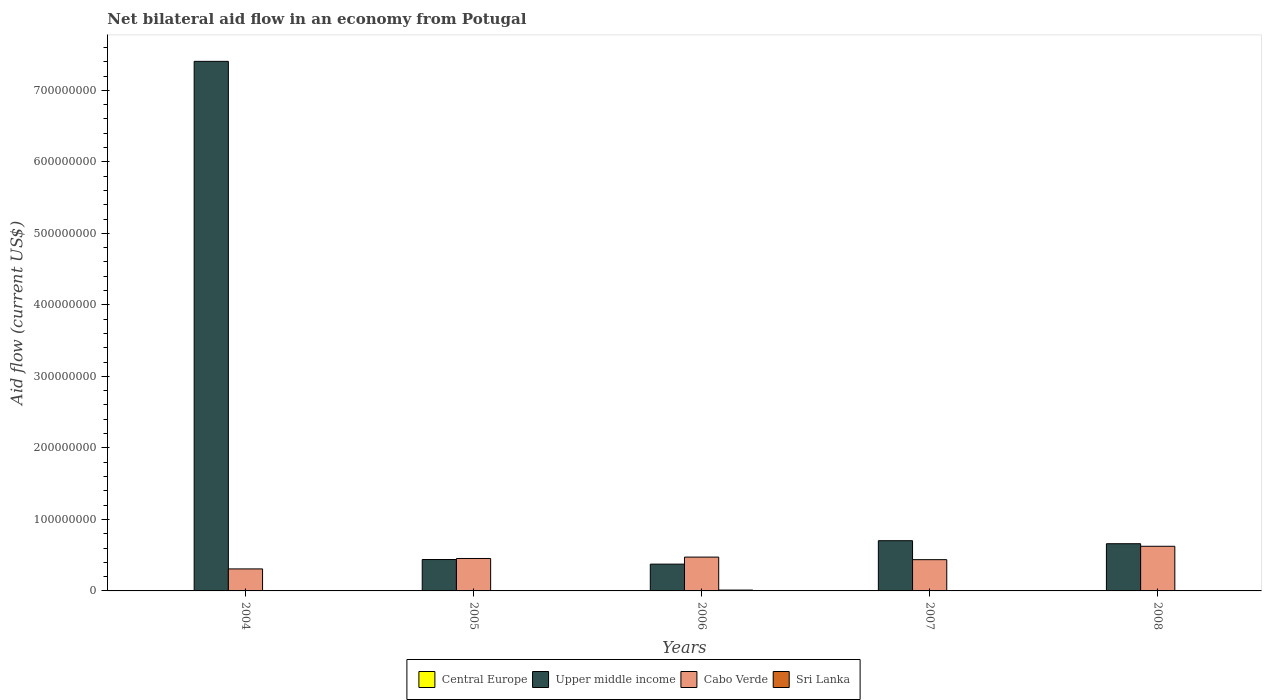How many groups of bars are there?
Your answer should be compact. 5. Are the number of bars on each tick of the X-axis equal?
Provide a succinct answer. Yes. How many bars are there on the 2nd tick from the right?
Make the answer very short. 4. What is the label of the 3rd group of bars from the left?
Provide a succinct answer. 2006. In how many cases, is the number of bars for a given year not equal to the number of legend labels?
Offer a terse response. 0. What is the net bilateral aid flow in Cabo Verde in 2005?
Offer a very short reply. 4.54e+07. Across all years, what is the maximum net bilateral aid flow in Upper middle income?
Offer a terse response. 7.41e+08. Across all years, what is the minimum net bilateral aid flow in Sri Lanka?
Ensure brevity in your answer.  10000. In which year was the net bilateral aid flow in Central Europe minimum?
Ensure brevity in your answer.  2005. What is the total net bilateral aid flow in Sri Lanka in the graph?
Ensure brevity in your answer.  1.89e+06. What is the difference between the net bilateral aid flow in Upper middle income in 2004 and that in 2005?
Your answer should be very brief. 6.97e+08. What is the difference between the net bilateral aid flow in Central Europe in 2008 and the net bilateral aid flow in Cabo Verde in 2007?
Provide a short and direct response. -4.36e+07. What is the average net bilateral aid flow in Central Europe per year?
Provide a short and direct response. 1.84e+05. In the year 2006, what is the difference between the net bilateral aid flow in Central Europe and net bilateral aid flow in Upper middle income?
Keep it short and to the point. -3.74e+07. Is the net bilateral aid flow in Sri Lanka in 2004 less than that in 2005?
Your response must be concise. Yes. What is the difference between the highest and the second highest net bilateral aid flow in Cabo Verde?
Provide a succinct answer. 1.51e+07. What is the difference between the highest and the lowest net bilateral aid flow in Upper middle income?
Provide a short and direct response. 7.03e+08. Is the sum of the net bilateral aid flow in Sri Lanka in 2004 and 2005 greater than the maximum net bilateral aid flow in Cabo Verde across all years?
Your answer should be compact. No. What does the 1st bar from the left in 2006 represents?
Your answer should be compact. Central Europe. What does the 4th bar from the right in 2008 represents?
Ensure brevity in your answer.  Central Europe. Are the values on the major ticks of Y-axis written in scientific E-notation?
Provide a succinct answer. No. Does the graph contain any zero values?
Your answer should be very brief. No. Where does the legend appear in the graph?
Your answer should be very brief. Bottom center. What is the title of the graph?
Provide a short and direct response. Net bilateral aid flow in an economy from Potugal. Does "Europe(all income levels)" appear as one of the legend labels in the graph?
Offer a very short reply. No. What is the label or title of the X-axis?
Provide a short and direct response. Years. What is the label or title of the Y-axis?
Your answer should be very brief. Aid flow (current US$). What is the Aid flow (current US$) in Central Europe in 2004?
Give a very brief answer. 5.50e+05. What is the Aid flow (current US$) in Upper middle income in 2004?
Keep it short and to the point. 7.41e+08. What is the Aid flow (current US$) in Cabo Verde in 2004?
Provide a succinct answer. 3.08e+07. What is the Aid flow (current US$) of Central Europe in 2005?
Your answer should be compact. 5.00e+04. What is the Aid flow (current US$) of Upper middle income in 2005?
Make the answer very short. 4.39e+07. What is the Aid flow (current US$) in Cabo Verde in 2005?
Give a very brief answer. 4.54e+07. What is the Aid flow (current US$) in Sri Lanka in 2005?
Keep it short and to the point. 5.40e+05. What is the Aid flow (current US$) in Upper middle income in 2006?
Give a very brief answer. 3.75e+07. What is the Aid flow (current US$) of Cabo Verde in 2006?
Keep it short and to the point. 4.73e+07. What is the Aid flow (current US$) of Sri Lanka in 2006?
Offer a terse response. 1.20e+06. What is the Aid flow (current US$) of Upper middle income in 2007?
Your response must be concise. 7.02e+07. What is the Aid flow (current US$) of Cabo Verde in 2007?
Your answer should be compact. 4.37e+07. What is the Aid flow (current US$) of Upper middle income in 2008?
Provide a short and direct response. 6.60e+07. What is the Aid flow (current US$) of Cabo Verde in 2008?
Your answer should be compact. 6.24e+07. What is the Aid flow (current US$) in Sri Lanka in 2008?
Your answer should be very brief. 3.00e+04. Across all years, what is the maximum Aid flow (current US$) in Central Europe?
Ensure brevity in your answer.  5.50e+05. Across all years, what is the maximum Aid flow (current US$) of Upper middle income?
Offer a very short reply. 7.41e+08. Across all years, what is the maximum Aid flow (current US$) of Cabo Verde?
Provide a succinct answer. 6.24e+07. Across all years, what is the maximum Aid flow (current US$) of Sri Lanka?
Offer a very short reply. 1.20e+06. Across all years, what is the minimum Aid flow (current US$) in Upper middle income?
Ensure brevity in your answer.  3.75e+07. Across all years, what is the minimum Aid flow (current US$) in Cabo Verde?
Offer a very short reply. 3.08e+07. Across all years, what is the minimum Aid flow (current US$) in Sri Lanka?
Give a very brief answer. 10000. What is the total Aid flow (current US$) of Central Europe in the graph?
Ensure brevity in your answer.  9.20e+05. What is the total Aid flow (current US$) in Upper middle income in the graph?
Make the answer very short. 9.58e+08. What is the total Aid flow (current US$) of Cabo Verde in the graph?
Provide a succinct answer. 2.30e+08. What is the total Aid flow (current US$) of Sri Lanka in the graph?
Your answer should be very brief. 1.89e+06. What is the difference between the Aid flow (current US$) of Upper middle income in 2004 and that in 2005?
Your response must be concise. 6.97e+08. What is the difference between the Aid flow (current US$) in Cabo Verde in 2004 and that in 2005?
Offer a terse response. -1.46e+07. What is the difference between the Aid flow (current US$) in Sri Lanka in 2004 and that in 2005?
Ensure brevity in your answer.  -4.30e+05. What is the difference between the Aid flow (current US$) in Upper middle income in 2004 and that in 2006?
Your answer should be very brief. 7.03e+08. What is the difference between the Aid flow (current US$) of Cabo Verde in 2004 and that in 2006?
Keep it short and to the point. -1.65e+07. What is the difference between the Aid flow (current US$) in Sri Lanka in 2004 and that in 2006?
Make the answer very short. -1.09e+06. What is the difference between the Aid flow (current US$) of Central Europe in 2004 and that in 2007?
Make the answer very short. 4.30e+05. What is the difference between the Aid flow (current US$) of Upper middle income in 2004 and that in 2007?
Keep it short and to the point. 6.70e+08. What is the difference between the Aid flow (current US$) of Cabo Verde in 2004 and that in 2007?
Your response must be concise. -1.29e+07. What is the difference between the Aid flow (current US$) in Sri Lanka in 2004 and that in 2007?
Provide a short and direct response. 1.00e+05. What is the difference between the Aid flow (current US$) of Upper middle income in 2004 and that in 2008?
Your response must be concise. 6.75e+08. What is the difference between the Aid flow (current US$) in Cabo Verde in 2004 and that in 2008?
Make the answer very short. -3.17e+07. What is the difference between the Aid flow (current US$) of Upper middle income in 2005 and that in 2006?
Make the answer very short. 6.44e+06. What is the difference between the Aid flow (current US$) in Cabo Verde in 2005 and that in 2006?
Provide a succinct answer. -1.94e+06. What is the difference between the Aid flow (current US$) in Sri Lanka in 2005 and that in 2006?
Provide a succinct answer. -6.60e+05. What is the difference between the Aid flow (current US$) of Upper middle income in 2005 and that in 2007?
Provide a short and direct response. -2.63e+07. What is the difference between the Aid flow (current US$) in Cabo Verde in 2005 and that in 2007?
Your answer should be very brief. 1.66e+06. What is the difference between the Aid flow (current US$) of Sri Lanka in 2005 and that in 2007?
Ensure brevity in your answer.  5.30e+05. What is the difference between the Aid flow (current US$) of Central Europe in 2005 and that in 2008?
Give a very brief answer. -7.00e+04. What is the difference between the Aid flow (current US$) in Upper middle income in 2005 and that in 2008?
Ensure brevity in your answer.  -2.21e+07. What is the difference between the Aid flow (current US$) of Cabo Verde in 2005 and that in 2008?
Your answer should be very brief. -1.71e+07. What is the difference between the Aid flow (current US$) in Sri Lanka in 2005 and that in 2008?
Provide a short and direct response. 5.10e+05. What is the difference between the Aid flow (current US$) in Upper middle income in 2006 and that in 2007?
Give a very brief answer. -3.28e+07. What is the difference between the Aid flow (current US$) of Cabo Verde in 2006 and that in 2007?
Make the answer very short. 3.60e+06. What is the difference between the Aid flow (current US$) in Sri Lanka in 2006 and that in 2007?
Provide a succinct answer. 1.19e+06. What is the difference between the Aid flow (current US$) in Central Europe in 2006 and that in 2008?
Provide a succinct answer. -4.00e+04. What is the difference between the Aid flow (current US$) in Upper middle income in 2006 and that in 2008?
Your answer should be compact. -2.85e+07. What is the difference between the Aid flow (current US$) of Cabo Verde in 2006 and that in 2008?
Offer a very short reply. -1.51e+07. What is the difference between the Aid flow (current US$) of Sri Lanka in 2006 and that in 2008?
Provide a succinct answer. 1.17e+06. What is the difference between the Aid flow (current US$) of Upper middle income in 2007 and that in 2008?
Offer a terse response. 4.22e+06. What is the difference between the Aid flow (current US$) of Cabo Verde in 2007 and that in 2008?
Ensure brevity in your answer.  -1.87e+07. What is the difference between the Aid flow (current US$) in Central Europe in 2004 and the Aid flow (current US$) in Upper middle income in 2005?
Your answer should be compact. -4.34e+07. What is the difference between the Aid flow (current US$) of Central Europe in 2004 and the Aid flow (current US$) of Cabo Verde in 2005?
Give a very brief answer. -4.48e+07. What is the difference between the Aid flow (current US$) in Upper middle income in 2004 and the Aid flow (current US$) in Cabo Verde in 2005?
Offer a terse response. 6.95e+08. What is the difference between the Aid flow (current US$) in Upper middle income in 2004 and the Aid flow (current US$) in Sri Lanka in 2005?
Make the answer very short. 7.40e+08. What is the difference between the Aid flow (current US$) in Cabo Verde in 2004 and the Aid flow (current US$) in Sri Lanka in 2005?
Offer a terse response. 3.02e+07. What is the difference between the Aid flow (current US$) in Central Europe in 2004 and the Aid flow (current US$) in Upper middle income in 2006?
Make the answer very short. -3.69e+07. What is the difference between the Aid flow (current US$) in Central Europe in 2004 and the Aid flow (current US$) in Cabo Verde in 2006?
Provide a short and direct response. -4.68e+07. What is the difference between the Aid flow (current US$) in Central Europe in 2004 and the Aid flow (current US$) in Sri Lanka in 2006?
Make the answer very short. -6.50e+05. What is the difference between the Aid flow (current US$) in Upper middle income in 2004 and the Aid flow (current US$) in Cabo Verde in 2006?
Your answer should be very brief. 6.93e+08. What is the difference between the Aid flow (current US$) in Upper middle income in 2004 and the Aid flow (current US$) in Sri Lanka in 2006?
Ensure brevity in your answer.  7.39e+08. What is the difference between the Aid flow (current US$) in Cabo Verde in 2004 and the Aid flow (current US$) in Sri Lanka in 2006?
Ensure brevity in your answer.  2.96e+07. What is the difference between the Aid flow (current US$) in Central Europe in 2004 and the Aid flow (current US$) in Upper middle income in 2007?
Provide a succinct answer. -6.97e+07. What is the difference between the Aid flow (current US$) of Central Europe in 2004 and the Aid flow (current US$) of Cabo Verde in 2007?
Your answer should be very brief. -4.32e+07. What is the difference between the Aid flow (current US$) in Central Europe in 2004 and the Aid flow (current US$) in Sri Lanka in 2007?
Make the answer very short. 5.40e+05. What is the difference between the Aid flow (current US$) in Upper middle income in 2004 and the Aid flow (current US$) in Cabo Verde in 2007?
Keep it short and to the point. 6.97e+08. What is the difference between the Aid flow (current US$) in Upper middle income in 2004 and the Aid flow (current US$) in Sri Lanka in 2007?
Your answer should be very brief. 7.41e+08. What is the difference between the Aid flow (current US$) of Cabo Verde in 2004 and the Aid flow (current US$) of Sri Lanka in 2007?
Provide a succinct answer. 3.08e+07. What is the difference between the Aid flow (current US$) of Central Europe in 2004 and the Aid flow (current US$) of Upper middle income in 2008?
Keep it short and to the point. -6.54e+07. What is the difference between the Aid flow (current US$) in Central Europe in 2004 and the Aid flow (current US$) in Cabo Verde in 2008?
Ensure brevity in your answer.  -6.19e+07. What is the difference between the Aid flow (current US$) of Central Europe in 2004 and the Aid flow (current US$) of Sri Lanka in 2008?
Keep it short and to the point. 5.20e+05. What is the difference between the Aid flow (current US$) in Upper middle income in 2004 and the Aid flow (current US$) in Cabo Verde in 2008?
Your response must be concise. 6.78e+08. What is the difference between the Aid flow (current US$) of Upper middle income in 2004 and the Aid flow (current US$) of Sri Lanka in 2008?
Your answer should be very brief. 7.40e+08. What is the difference between the Aid flow (current US$) of Cabo Verde in 2004 and the Aid flow (current US$) of Sri Lanka in 2008?
Offer a terse response. 3.07e+07. What is the difference between the Aid flow (current US$) in Central Europe in 2005 and the Aid flow (current US$) in Upper middle income in 2006?
Ensure brevity in your answer.  -3.74e+07. What is the difference between the Aid flow (current US$) of Central Europe in 2005 and the Aid flow (current US$) of Cabo Verde in 2006?
Make the answer very short. -4.72e+07. What is the difference between the Aid flow (current US$) in Central Europe in 2005 and the Aid flow (current US$) in Sri Lanka in 2006?
Keep it short and to the point. -1.15e+06. What is the difference between the Aid flow (current US$) of Upper middle income in 2005 and the Aid flow (current US$) of Cabo Verde in 2006?
Keep it short and to the point. -3.39e+06. What is the difference between the Aid flow (current US$) of Upper middle income in 2005 and the Aid flow (current US$) of Sri Lanka in 2006?
Make the answer very short. 4.27e+07. What is the difference between the Aid flow (current US$) in Cabo Verde in 2005 and the Aid flow (current US$) in Sri Lanka in 2006?
Your response must be concise. 4.42e+07. What is the difference between the Aid flow (current US$) of Central Europe in 2005 and the Aid flow (current US$) of Upper middle income in 2007?
Provide a succinct answer. -7.02e+07. What is the difference between the Aid flow (current US$) of Central Europe in 2005 and the Aid flow (current US$) of Cabo Verde in 2007?
Provide a short and direct response. -4.36e+07. What is the difference between the Aid flow (current US$) in Central Europe in 2005 and the Aid flow (current US$) in Sri Lanka in 2007?
Ensure brevity in your answer.  4.00e+04. What is the difference between the Aid flow (current US$) of Upper middle income in 2005 and the Aid flow (current US$) of Sri Lanka in 2007?
Offer a very short reply. 4.39e+07. What is the difference between the Aid flow (current US$) of Cabo Verde in 2005 and the Aid flow (current US$) of Sri Lanka in 2007?
Offer a terse response. 4.54e+07. What is the difference between the Aid flow (current US$) of Central Europe in 2005 and the Aid flow (current US$) of Upper middle income in 2008?
Keep it short and to the point. -6.60e+07. What is the difference between the Aid flow (current US$) in Central Europe in 2005 and the Aid flow (current US$) in Cabo Verde in 2008?
Provide a succinct answer. -6.24e+07. What is the difference between the Aid flow (current US$) in Upper middle income in 2005 and the Aid flow (current US$) in Cabo Verde in 2008?
Your answer should be very brief. -1.85e+07. What is the difference between the Aid flow (current US$) in Upper middle income in 2005 and the Aid flow (current US$) in Sri Lanka in 2008?
Provide a short and direct response. 4.39e+07. What is the difference between the Aid flow (current US$) in Cabo Verde in 2005 and the Aid flow (current US$) in Sri Lanka in 2008?
Make the answer very short. 4.53e+07. What is the difference between the Aid flow (current US$) of Central Europe in 2006 and the Aid flow (current US$) of Upper middle income in 2007?
Keep it short and to the point. -7.01e+07. What is the difference between the Aid flow (current US$) in Central Europe in 2006 and the Aid flow (current US$) in Cabo Verde in 2007?
Keep it short and to the point. -4.36e+07. What is the difference between the Aid flow (current US$) in Central Europe in 2006 and the Aid flow (current US$) in Sri Lanka in 2007?
Make the answer very short. 7.00e+04. What is the difference between the Aid flow (current US$) in Upper middle income in 2006 and the Aid flow (current US$) in Cabo Verde in 2007?
Provide a short and direct response. -6.23e+06. What is the difference between the Aid flow (current US$) of Upper middle income in 2006 and the Aid flow (current US$) of Sri Lanka in 2007?
Ensure brevity in your answer.  3.75e+07. What is the difference between the Aid flow (current US$) of Cabo Verde in 2006 and the Aid flow (current US$) of Sri Lanka in 2007?
Your answer should be compact. 4.73e+07. What is the difference between the Aid flow (current US$) in Central Europe in 2006 and the Aid flow (current US$) in Upper middle income in 2008?
Make the answer very short. -6.59e+07. What is the difference between the Aid flow (current US$) in Central Europe in 2006 and the Aid flow (current US$) in Cabo Verde in 2008?
Your response must be concise. -6.24e+07. What is the difference between the Aid flow (current US$) in Upper middle income in 2006 and the Aid flow (current US$) in Cabo Verde in 2008?
Offer a terse response. -2.50e+07. What is the difference between the Aid flow (current US$) in Upper middle income in 2006 and the Aid flow (current US$) in Sri Lanka in 2008?
Your answer should be compact. 3.74e+07. What is the difference between the Aid flow (current US$) of Cabo Verde in 2006 and the Aid flow (current US$) of Sri Lanka in 2008?
Offer a terse response. 4.73e+07. What is the difference between the Aid flow (current US$) in Central Europe in 2007 and the Aid flow (current US$) in Upper middle income in 2008?
Provide a succinct answer. -6.59e+07. What is the difference between the Aid flow (current US$) in Central Europe in 2007 and the Aid flow (current US$) in Cabo Verde in 2008?
Offer a terse response. -6.23e+07. What is the difference between the Aid flow (current US$) of Central Europe in 2007 and the Aid flow (current US$) of Sri Lanka in 2008?
Provide a short and direct response. 9.00e+04. What is the difference between the Aid flow (current US$) of Upper middle income in 2007 and the Aid flow (current US$) of Cabo Verde in 2008?
Your answer should be compact. 7.79e+06. What is the difference between the Aid flow (current US$) of Upper middle income in 2007 and the Aid flow (current US$) of Sri Lanka in 2008?
Provide a succinct answer. 7.02e+07. What is the difference between the Aid flow (current US$) in Cabo Verde in 2007 and the Aid flow (current US$) in Sri Lanka in 2008?
Provide a succinct answer. 4.37e+07. What is the average Aid flow (current US$) of Central Europe per year?
Offer a terse response. 1.84e+05. What is the average Aid flow (current US$) of Upper middle income per year?
Provide a succinct answer. 1.92e+08. What is the average Aid flow (current US$) in Cabo Verde per year?
Your answer should be very brief. 4.59e+07. What is the average Aid flow (current US$) of Sri Lanka per year?
Ensure brevity in your answer.  3.78e+05. In the year 2004, what is the difference between the Aid flow (current US$) in Central Europe and Aid flow (current US$) in Upper middle income?
Keep it short and to the point. -7.40e+08. In the year 2004, what is the difference between the Aid flow (current US$) in Central Europe and Aid flow (current US$) in Cabo Verde?
Provide a succinct answer. -3.02e+07. In the year 2004, what is the difference between the Aid flow (current US$) in Central Europe and Aid flow (current US$) in Sri Lanka?
Your answer should be very brief. 4.40e+05. In the year 2004, what is the difference between the Aid flow (current US$) of Upper middle income and Aid flow (current US$) of Cabo Verde?
Your answer should be very brief. 7.10e+08. In the year 2004, what is the difference between the Aid flow (current US$) in Upper middle income and Aid flow (current US$) in Sri Lanka?
Ensure brevity in your answer.  7.40e+08. In the year 2004, what is the difference between the Aid flow (current US$) of Cabo Verde and Aid flow (current US$) of Sri Lanka?
Offer a terse response. 3.07e+07. In the year 2005, what is the difference between the Aid flow (current US$) of Central Europe and Aid flow (current US$) of Upper middle income?
Offer a very short reply. -4.39e+07. In the year 2005, what is the difference between the Aid flow (current US$) in Central Europe and Aid flow (current US$) in Cabo Verde?
Your answer should be compact. -4.53e+07. In the year 2005, what is the difference between the Aid flow (current US$) of Central Europe and Aid flow (current US$) of Sri Lanka?
Give a very brief answer. -4.90e+05. In the year 2005, what is the difference between the Aid flow (current US$) of Upper middle income and Aid flow (current US$) of Cabo Verde?
Your response must be concise. -1.45e+06. In the year 2005, what is the difference between the Aid flow (current US$) of Upper middle income and Aid flow (current US$) of Sri Lanka?
Offer a very short reply. 4.34e+07. In the year 2005, what is the difference between the Aid flow (current US$) in Cabo Verde and Aid flow (current US$) in Sri Lanka?
Your answer should be very brief. 4.48e+07. In the year 2006, what is the difference between the Aid flow (current US$) of Central Europe and Aid flow (current US$) of Upper middle income?
Offer a very short reply. -3.74e+07. In the year 2006, what is the difference between the Aid flow (current US$) in Central Europe and Aid flow (current US$) in Cabo Verde?
Your response must be concise. -4.72e+07. In the year 2006, what is the difference between the Aid flow (current US$) of Central Europe and Aid flow (current US$) of Sri Lanka?
Offer a terse response. -1.12e+06. In the year 2006, what is the difference between the Aid flow (current US$) in Upper middle income and Aid flow (current US$) in Cabo Verde?
Keep it short and to the point. -9.83e+06. In the year 2006, what is the difference between the Aid flow (current US$) of Upper middle income and Aid flow (current US$) of Sri Lanka?
Make the answer very short. 3.63e+07. In the year 2006, what is the difference between the Aid flow (current US$) in Cabo Verde and Aid flow (current US$) in Sri Lanka?
Keep it short and to the point. 4.61e+07. In the year 2007, what is the difference between the Aid flow (current US$) of Central Europe and Aid flow (current US$) of Upper middle income?
Ensure brevity in your answer.  -7.01e+07. In the year 2007, what is the difference between the Aid flow (current US$) of Central Europe and Aid flow (current US$) of Cabo Verde?
Give a very brief answer. -4.36e+07. In the year 2007, what is the difference between the Aid flow (current US$) in Central Europe and Aid flow (current US$) in Sri Lanka?
Ensure brevity in your answer.  1.10e+05. In the year 2007, what is the difference between the Aid flow (current US$) of Upper middle income and Aid flow (current US$) of Cabo Verde?
Your answer should be very brief. 2.65e+07. In the year 2007, what is the difference between the Aid flow (current US$) of Upper middle income and Aid flow (current US$) of Sri Lanka?
Ensure brevity in your answer.  7.02e+07. In the year 2007, what is the difference between the Aid flow (current US$) in Cabo Verde and Aid flow (current US$) in Sri Lanka?
Keep it short and to the point. 4.37e+07. In the year 2008, what is the difference between the Aid flow (current US$) in Central Europe and Aid flow (current US$) in Upper middle income?
Provide a short and direct response. -6.59e+07. In the year 2008, what is the difference between the Aid flow (current US$) in Central Europe and Aid flow (current US$) in Cabo Verde?
Your response must be concise. -6.23e+07. In the year 2008, what is the difference between the Aid flow (current US$) in Central Europe and Aid flow (current US$) in Sri Lanka?
Give a very brief answer. 9.00e+04. In the year 2008, what is the difference between the Aid flow (current US$) in Upper middle income and Aid flow (current US$) in Cabo Verde?
Give a very brief answer. 3.57e+06. In the year 2008, what is the difference between the Aid flow (current US$) of Upper middle income and Aid flow (current US$) of Sri Lanka?
Make the answer very short. 6.60e+07. In the year 2008, what is the difference between the Aid flow (current US$) in Cabo Verde and Aid flow (current US$) in Sri Lanka?
Offer a very short reply. 6.24e+07. What is the ratio of the Aid flow (current US$) in Upper middle income in 2004 to that in 2005?
Ensure brevity in your answer.  16.86. What is the ratio of the Aid flow (current US$) in Cabo Verde in 2004 to that in 2005?
Offer a very short reply. 0.68. What is the ratio of the Aid flow (current US$) in Sri Lanka in 2004 to that in 2005?
Your response must be concise. 0.2. What is the ratio of the Aid flow (current US$) of Central Europe in 2004 to that in 2006?
Offer a terse response. 6.88. What is the ratio of the Aid flow (current US$) in Upper middle income in 2004 to that in 2006?
Make the answer very short. 19.76. What is the ratio of the Aid flow (current US$) in Cabo Verde in 2004 to that in 2006?
Provide a short and direct response. 0.65. What is the ratio of the Aid flow (current US$) of Sri Lanka in 2004 to that in 2006?
Your response must be concise. 0.09. What is the ratio of the Aid flow (current US$) in Central Europe in 2004 to that in 2007?
Ensure brevity in your answer.  4.58. What is the ratio of the Aid flow (current US$) of Upper middle income in 2004 to that in 2007?
Offer a very short reply. 10.55. What is the ratio of the Aid flow (current US$) in Cabo Verde in 2004 to that in 2007?
Your answer should be compact. 0.7. What is the ratio of the Aid flow (current US$) of Central Europe in 2004 to that in 2008?
Ensure brevity in your answer.  4.58. What is the ratio of the Aid flow (current US$) in Upper middle income in 2004 to that in 2008?
Provide a succinct answer. 11.22. What is the ratio of the Aid flow (current US$) in Cabo Verde in 2004 to that in 2008?
Your response must be concise. 0.49. What is the ratio of the Aid flow (current US$) of Sri Lanka in 2004 to that in 2008?
Provide a succinct answer. 3.67. What is the ratio of the Aid flow (current US$) of Upper middle income in 2005 to that in 2006?
Give a very brief answer. 1.17. What is the ratio of the Aid flow (current US$) in Sri Lanka in 2005 to that in 2006?
Your answer should be very brief. 0.45. What is the ratio of the Aid flow (current US$) in Central Europe in 2005 to that in 2007?
Make the answer very short. 0.42. What is the ratio of the Aid flow (current US$) of Upper middle income in 2005 to that in 2007?
Ensure brevity in your answer.  0.63. What is the ratio of the Aid flow (current US$) of Cabo Verde in 2005 to that in 2007?
Your response must be concise. 1.04. What is the ratio of the Aid flow (current US$) in Central Europe in 2005 to that in 2008?
Give a very brief answer. 0.42. What is the ratio of the Aid flow (current US$) of Upper middle income in 2005 to that in 2008?
Give a very brief answer. 0.67. What is the ratio of the Aid flow (current US$) of Cabo Verde in 2005 to that in 2008?
Provide a short and direct response. 0.73. What is the ratio of the Aid flow (current US$) of Sri Lanka in 2005 to that in 2008?
Make the answer very short. 18. What is the ratio of the Aid flow (current US$) of Central Europe in 2006 to that in 2007?
Your answer should be compact. 0.67. What is the ratio of the Aid flow (current US$) in Upper middle income in 2006 to that in 2007?
Provide a succinct answer. 0.53. What is the ratio of the Aid flow (current US$) in Cabo Verde in 2006 to that in 2007?
Offer a very short reply. 1.08. What is the ratio of the Aid flow (current US$) in Sri Lanka in 2006 to that in 2007?
Give a very brief answer. 120. What is the ratio of the Aid flow (current US$) in Central Europe in 2006 to that in 2008?
Your response must be concise. 0.67. What is the ratio of the Aid flow (current US$) in Upper middle income in 2006 to that in 2008?
Offer a very short reply. 0.57. What is the ratio of the Aid flow (current US$) of Cabo Verde in 2006 to that in 2008?
Offer a terse response. 0.76. What is the ratio of the Aid flow (current US$) in Upper middle income in 2007 to that in 2008?
Offer a terse response. 1.06. What is the difference between the highest and the second highest Aid flow (current US$) of Central Europe?
Your answer should be very brief. 4.30e+05. What is the difference between the highest and the second highest Aid flow (current US$) in Upper middle income?
Give a very brief answer. 6.70e+08. What is the difference between the highest and the second highest Aid flow (current US$) of Cabo Verde?
Offer a very short reply. 1.51e+07. What is the difference between the highest and the second highest Aid flow (current US$) of Sri Lanka?
Your answer should be very brief. 6.60e+05. What is the difference between the highest and the lowest Aid flow (current US$) of Central Europe?
Offer a very short reply. 5.00e+05. What is the difference between the highest and the lowest Aid flow (current US$) of Upper middle income?
Your answer should be compact. 7.03e+08. What is the difference between the highest and the lowest Aid flow (current US$) of Cabo Verde?
Your response must be concise. 3.17e+07. What is the difference between the highest and the lowest Aid flow (current US$) of Sri Lanka?
Make the answer very short. 1.19e+06. 